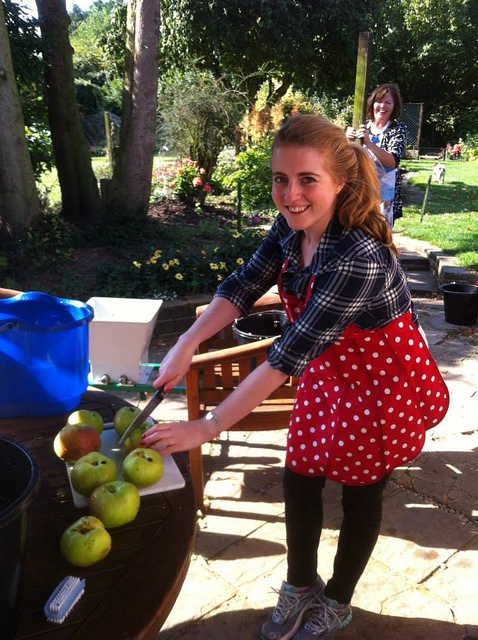Describe the objects in this image and their specific colors. I can see people in black, brown, and maroon tones, dining table in black, olive, and maroon tones, chair in black, maroon, tan, and brown tones, people in black, gray, brown, and white tones, and apple in black and olive tones in this image. 